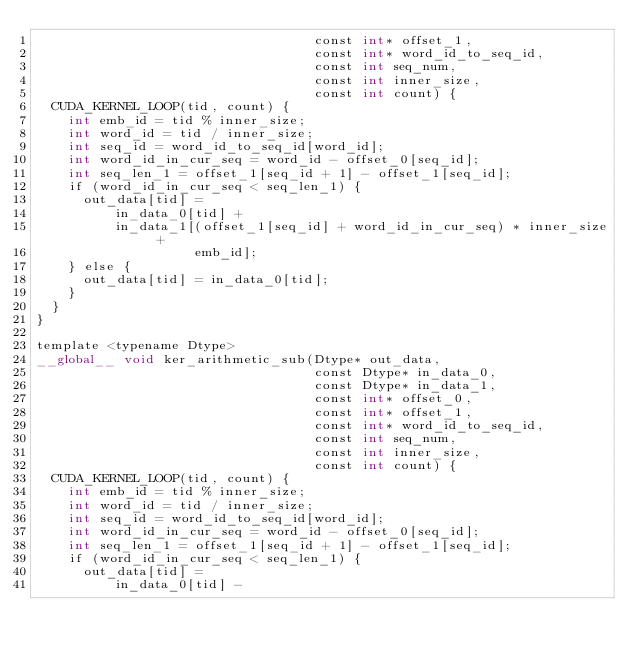<code> <loc_0><loc_0><loc_500><loc_500><_Cuda_>                                   const int* offset_1,
                                   const int* word_id_to_seq_id,
                                   const int seq_num,
                                   const int inner_size,
                                   const int count) {
  CUDA_KERNEL_LOOP(tid, count) {
    int emb_id = tid % inner_size;
    int word_id = tid / inner_size;
    int seq_id = word_id_to_seq_id[word_id];
    int word_id_in_cur_seq = word_id - offset_0[seq_id];
    int seq_len_1 = offset_1[seq_id + 1] - offset_1[seq_id];
    if (word_id_in_cur_seq < seq_len_1) {
      out_data[tid] =
          in_data_0[tid] +
          in_data_1[(offset_1[seq_id] + word_id_in_cur_seq) * inner_size +
                    emb_id];
    } else {
      out_data[tid] = in_data_0[tid];
    }
  }
}

template <typename Dtype>
__global__ void ker_arithmetic_sub(Dtype* out_data,
                                   const Dtype* in_data_0,
                                   const Dtype* in_data_1,
                                   const int* offset_0,
                                   const int* offset_1,
                                   const int* word_id_to_seq_id,
                                   const int seq_num,
                                   const int inner_size,
                                   const int count) {
  CUDA_KERNEL_LOOP(tid, count) {
    int emb_id = tid % inner_size;
    int word_id = tid / inner_size;
    int seq_id = word_id_to_seq_id[word_id];
    int word_id_in_cur_seq = word_id - offset_0[seq_id];
    int seq_len_1 = offset_1[seq_id + 1] - offset_1[seq_id];
    if (word_id_in_cur_seq < seq_len_1) {
      out_data[tid] =
          in_data_0[tid] -</code> 